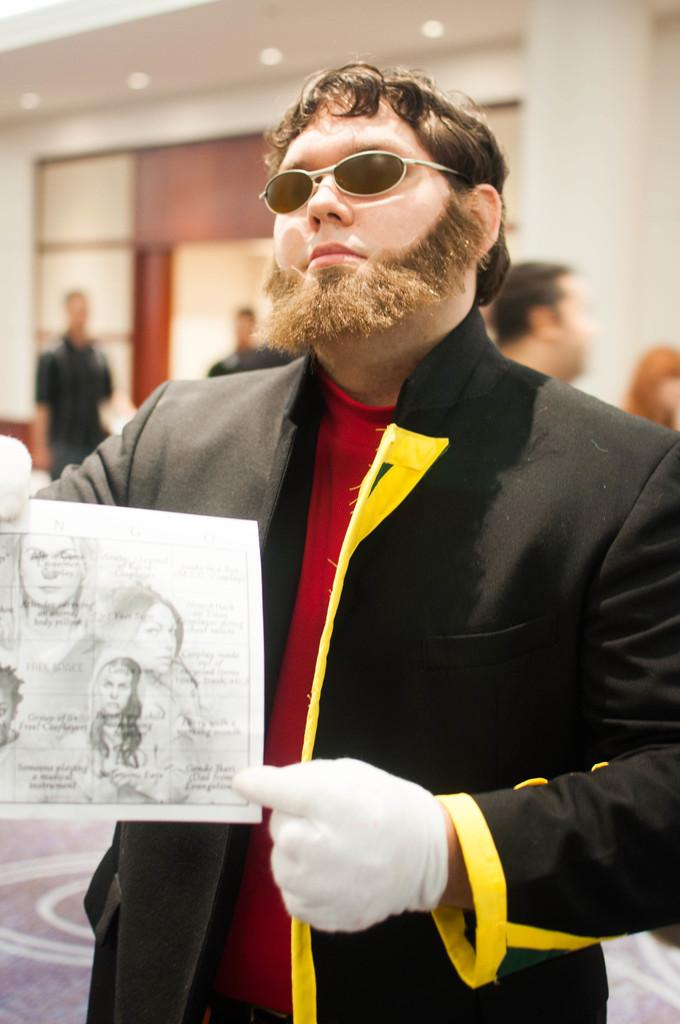Who is the main subject in the image? There is a man in the image. What is the man wearing? The man is wearing a black coat. What is the man holding in the image? The man is holding a paper. Can you describe the setting of the image? The image appears to be taken inside a building. How many people are visible in the background of the image? There are many people in the background of the image. What type of brick is the man crushing in the image? There is no brick present in the image, nor is the man crushing anything. 